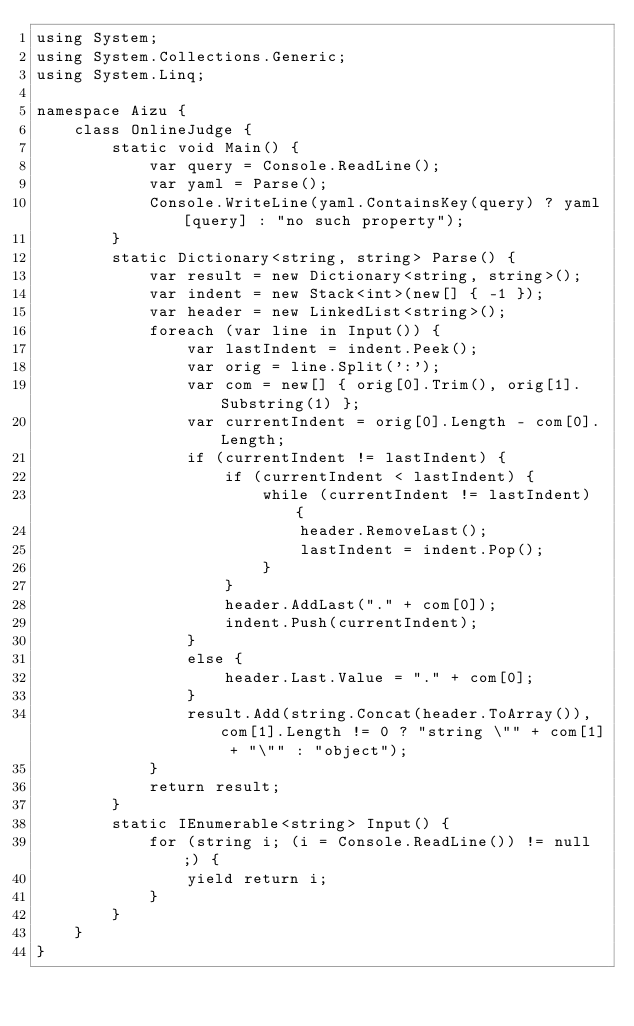<code> <loc_0><loc_0><loc_500><loc_500><_C#_>using System;
using System.Collections.Generic;
using System.Linq;

namespace Aizu {
    class OnlineJudge {
        static void Main() {
            var query = Console.ReadLine();
            var yaml = Parse();
            Console.WriteLine(yaml.ContainsKey(query) ? yaml[query] : "no such property");
        }
        static Dictionary<string, string> Parse() {
            var result = new Dictionary<string, string>();
            var indent = new Stack<int>(new[] { -1 });
            var header = new LinkedList<string>();
            foreach (var line in Input()) {
                var lastIndent = indent.Peek();
                var orig = line.Split(':');
                var com = new[] { orig[0].Trim(), orig[1].Substring(1) };
                var currentIndent = orig[0].Length - com[0].Length;
                if (currentIndent != lastIndent) {
                    if (currentIndent < lastIndent) {
                        while (currentIndent != lastIndent) {
                            header.RemoveLast();
                            lastIndent = indent.Pop();
                        }
                    }
                    header.AddLast("." + com[0]);
                    indent.Push(currentIndent);
                }
                else {
                    header.Last.Value = "." + com[0];
                }
                result.Add(string.Concat(header.ToArray()), com[1].Length != 0 ? "string \"" + com[1] + "\"" : "object");
            }
            return result;
        }
        static IEnumerable<string> Input() {
            for (string i; (i = Console.ReadLine()) != null;) {
                yield return i;
            }
        }
    }
}</code> 